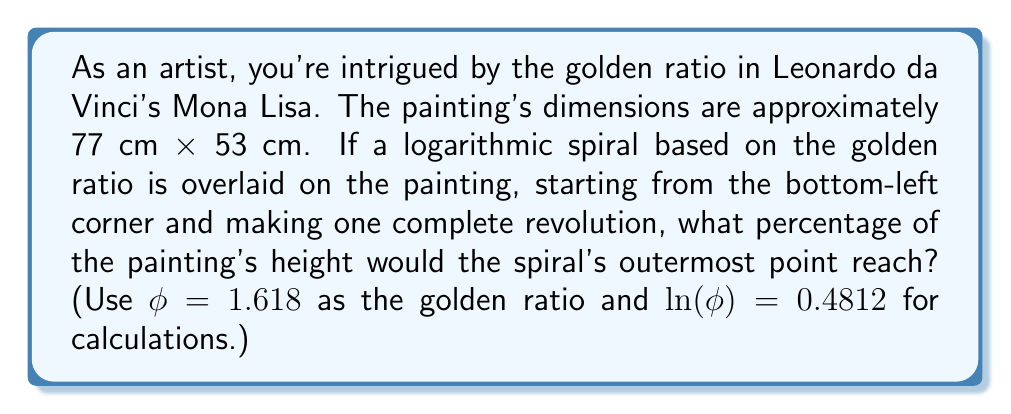Could you help me with this problem? Let's approach this step-by-step:

1) The logarithmic spiral based on the golden ratio is described by the polar equation:
   
   $$r = ae^{b\theta}$$

   where $a$ is the starting radius, $b = \frac{1}{\ln(\phi)} = \frac{1}{0.4812} \approx 2.0781$, and $\theta$ is the angle in radians.

2) One complete revolution is $2\pi$ radians. We need to find the ratio of the final radius to the initial radius:

   $$\frac{r_{final}}{r_{initial}} = e^{b(2\pi)} = e^{2\pi / \ln(\phi)}$$

3) Let's calculate this:
   
   $$e^{2\pi / \ln(\phi)} = e^{2\pi / 0.4812} \approx 512.5$$

4) This means the spiral grows by a factor of about 512.5 in one revolution.

5) The painting's height is 77 cm. If we start the spiral at the bottom-left corner, it needs to grow by a factor of 77 to reach the full height.

6) To find what percentage of the height the spiral reaches, we calculate:

   $$\frac{512.5}{77} \times 100\% \approx 665.6\%$$

This means the spiral would actually exceed the height of the painting by quite a lot.
Answer: The logarithmic spiral would reach approximately 665.6% of the painting's height, far exceeding the dimensions of the Mona Lisa. 